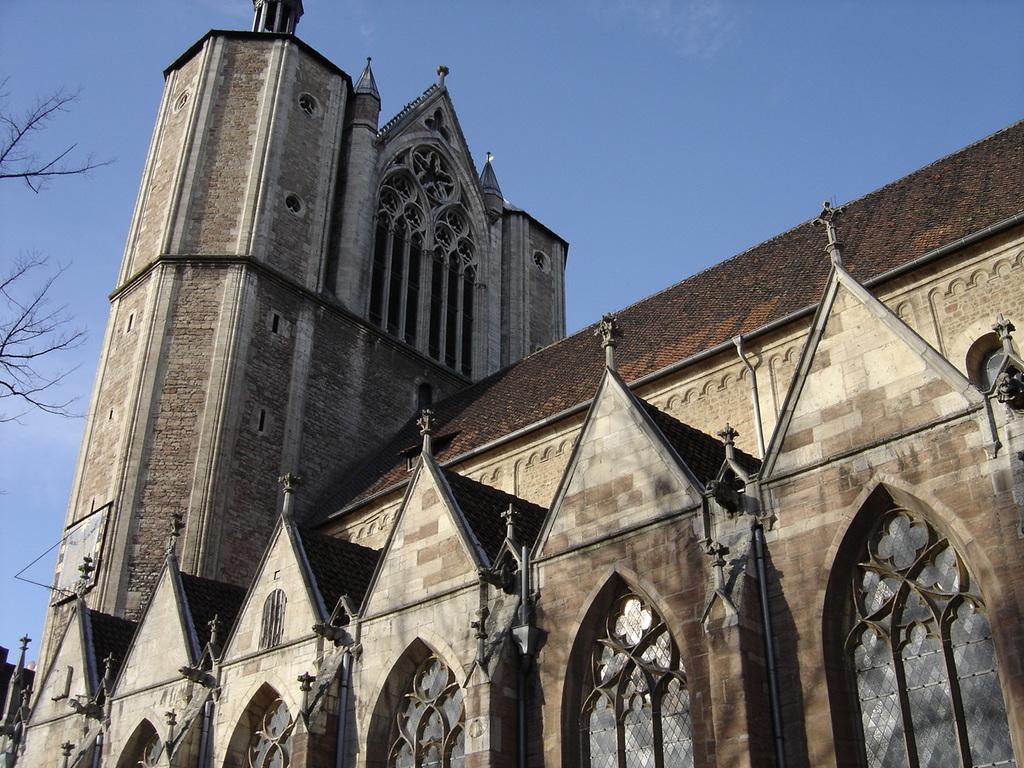Describe this image in one or two sentences. In this image I can see a building in the front and on the left side of the image I can see branches of a tree. I can also see the sky in the background. 